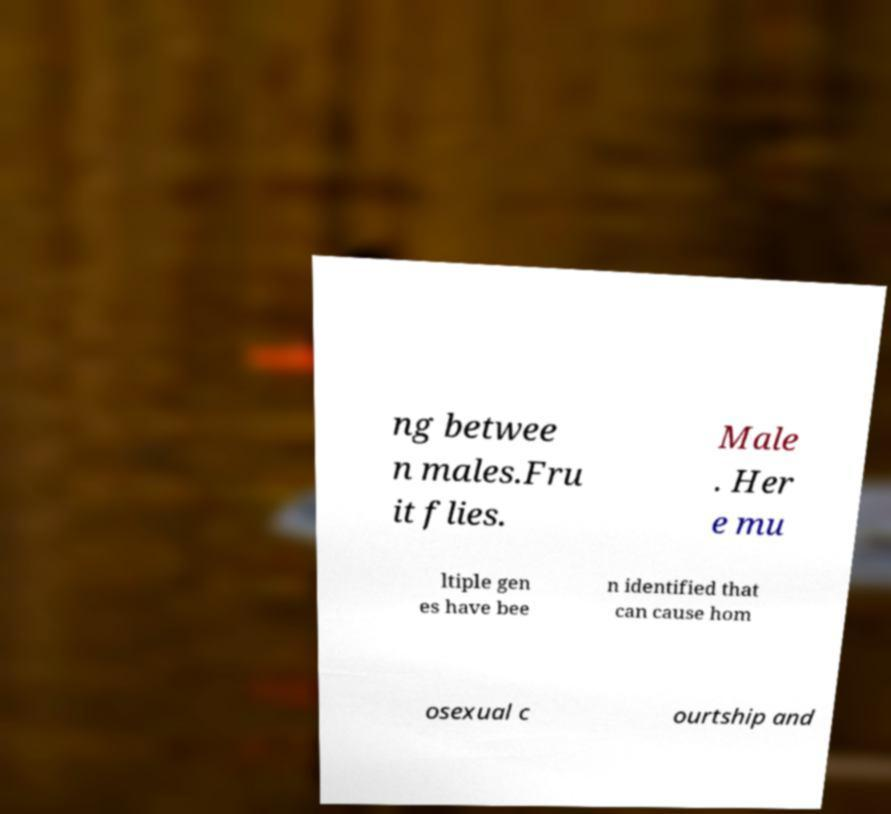There's text embedded in this image that I need extracted. Can you transcribe it verbatim? ng betwee n males.Fru it flies. Male . Her e mu ltiple gen es have bee n identified that can cause hom osexual c ourtship and 